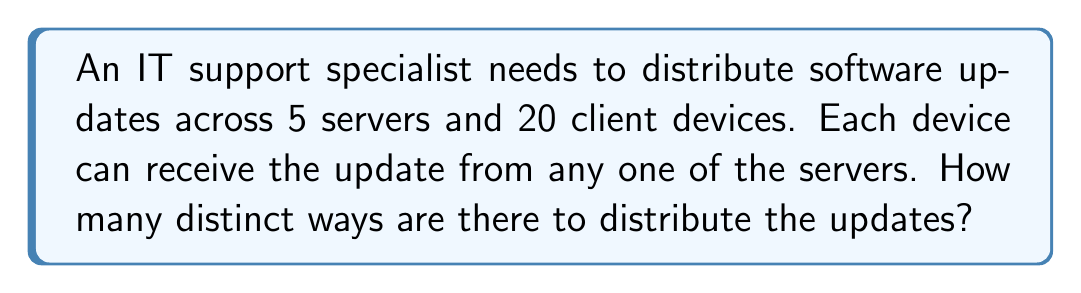Give your solution to this math problem. Let's approach this step-by-step:

1) For each client device, we need to choose one server from which it will receive the update.

2) This is a case of making independent choices for each client device, where each choice has 5 options (the 5 servers).

3) When we have independent choices, we multiply the number of options for each choice.

4) In this case, we're making 20 independent choices (one for each client device), and each choice has 5 options.

5) Therefore, we can use the multiplication principle of counting.

6) The total number of ways to distribute the updates is:

   $$5 \times 5 \times 5 \times ... \times 5$$ (20 times)

7) This can be written as an exponent:

   $$5^{20}$$

8) Calculate:
   $$5^{20} = 95,367,431,640,625$$

This large number represents all possible ways to distribute the updates, taking into account that each client device can independently receive its update from any of the 5 servers.
Answer: $5^{20}$ 